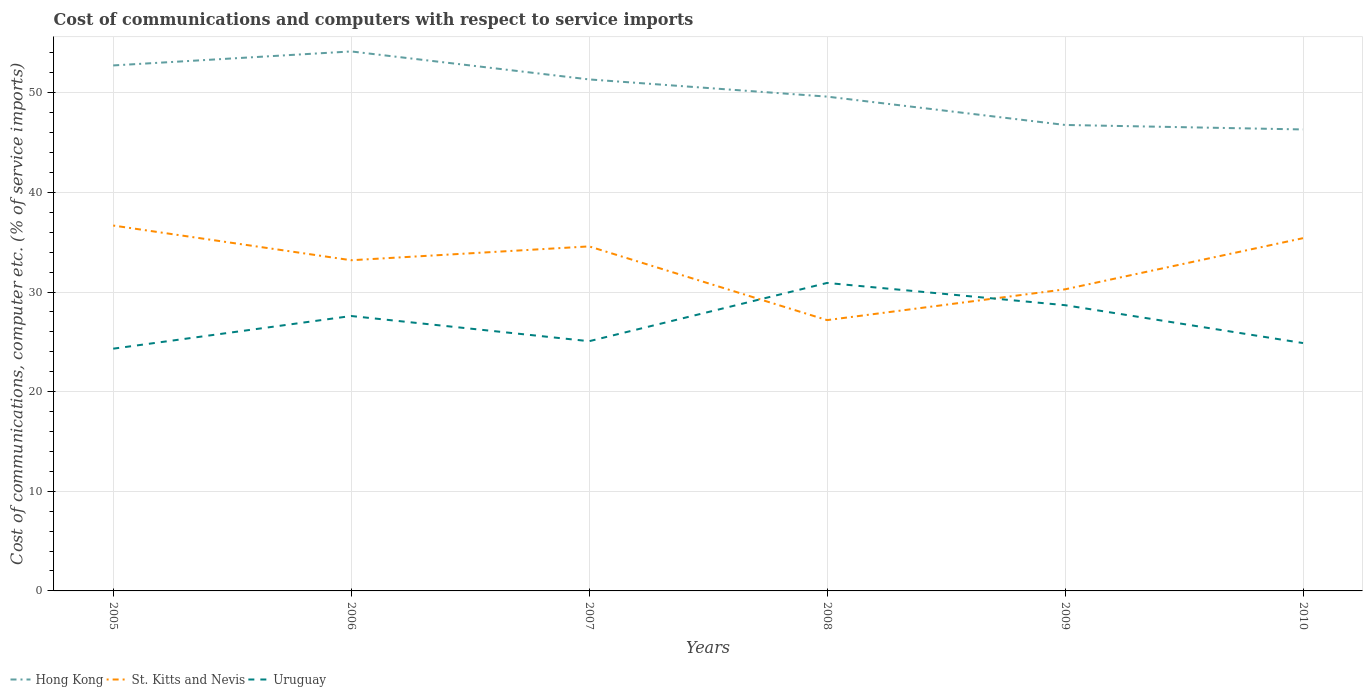How many different coloured lines are there?
Make the answer very short. 3. Does the line corresponding to Uruguay intersect with the line corresponding to Hong Kong?
Offer a terse response. No. Across all years, what is the maximum cost of communications and computers in Hong Kong?
Your answer should be very brief. 46.32. What is the total cost of communications and computers in Hong Kong in the graph?
Provide a succinct answer. 2.81. What is the difference between the highest and the second highest cost of communications and computers in Uruguay?
Offer a terse response. 6.6. Is the cost of communications and computers in Uruguay strictly greater than the cost of communications and computers in St. Kitts and Nevis over the years?
Your answer should be compact. No. How many lines are there?
Provide a succinct answer. 3. How many years are there in the graph?
Ensure brevity in your answer.  6. Are the values on the major ticks of Y-axis written in scientific E-notation?
Your answer should be very brief. No. Does the graph contain any zero values?
Keep it short and to the point. No. Where does the legend appear in the graph?
Ensure brevity in your answer.  Bottom left. How are the legend labels stacked?
Your answer should be compact. Horizontal. What is the title of the graph?
Ensure brevity in your answer.  Cost of communications and computers with respect to service imports. Does "Yemen, Rep." appear as one of the legend labels in the graph?
Give a very brief answer. No. What is the label or title of the Y-axis?
Offer a very short reply. Cost of communications, computer etc. (% of service imports). What is the Cost of communications, computer etc. (% of service imports) in Hong Kong in 2005?
Provide a short and direct response. 52.75. What is the Cost of communications, computer etc. (% of service imports) in St. Kitts and Nevis in 2005?
Offer a terse response. 36.68. What is the Cost of communications, computer etc. (% of service imports) of Uruguay in 2005?
Your response must be concise. 24.32. What is the Cost of communications, computer etc. (% of service imports) of Hong Kong in 2006?
Keep it short and to the point. 54.15. What is the Cost of communications, computer etc. (% of service imports) in St. Kitts and Nevis in 2006?
Offer a very short reply. 33.19. What is the Cost of communications, computer etc. (% of service imports) in Uruguay in 2006?
Keep it short and to the point. 27.6. What is the Cost of communications, computer etc. (% of service imports) of Hong Kong in 2007?
Make the answer very short. 51.34. What is the Cost of communications, computer etc. (% of service imports) of St. Kitts and Nevis in 2007?
Make the answer very short. 34.58. What is the Cost of communications, computer etc. (% of service imports) of Uruguay in 2007?
Keep it short and to the point. 25.07. What is the Cost of communications, computer etc. (% of service imports) of Hong Kong in 2008?
Give a very brief answer. 49.62. What is the Cost of communications, computer etc. (% of service imports) in St. Kitts and Nevis in 2008?
Provide a short and direct response. 27.18. What is the Cost of communications, computer etc. (% of service imports) of Uruguay in 2008?
Offer a very short reply. 30.91. What is the Cost of communications, computer etc. (% of service imports) of Hong Kong in 2009?
Provide a short and direct response. 46.77. What is the Cost of communications, computer etc. (% of service imports) of St. Kitts and Nevis in 2009?
Your answer should be compact. 30.27. What is the Cost of communications, computer etc. (% of service imports) of Uruguay in 2009?
Your answer should be very brief. 28.68. What is the Cost of communications, computer etc. (% of service imports) of Hong Kong in 2010?
Make the answer very short. 46.32. What is the Cost of communications, computer etc. (% of service imports) in St. Kitts and Nevis in 2010?
Your answer should be compact. 35.41. What is the Cost of communications, computer etc. (% of service imports) in Uruguay in 2010?
Offer a very short reply. 24.88. Across all years, what is the maximum Cost of communications, computer etc. (% of service imports) in Hong Kong?
Offer a terse response. 54.15. Across all years, what is the maximum Cost of communications, computer etc. (% of service imports) in St. Kitts and Nevis?
Your answer should be compact. 36.68. Across all years, what is the maximum Cost of communications, computer etc. (% of service imports) of Uruguay?
Offer a very short reply. 30.91. Across all years, what is the minimum Cost of communications, computer etc. (% of service imports) in Hong Kong?
Your answer should be compact. 46.32. Across all years, what is the minimum Cost of communications, computer etc. (% of service imports) of St. Kitts and Nevis?
Your response must be concise. 27.18. Across all years, what is the minimum Cost of communications, computer etc. (% of service imports) in Uruguay?
Ensure brevity in your answer.  24.32. What is the total Cost of communications, computer etc. (% of service imports) of Hong Kong in the graph?
Ensure brevity in your answer.  300.95. What is the total Cost of communications, computer etc. (% of service imports) in St. Kitts and Nevis in the graph?
Ensure brevity in your answer.  197.31. What is the total Cost of communications, computer etc. (% of service imports) in Uruguay in the graph?
Make the answer very short. 161.45. What is the difference between the Cost of communications, computer etc. (% of service imports) in Hong Kong in 2005 and that in 2006?
Make the answer very short. -1.41. What is the difference between the Cost of communications, computer etc. (% of service imports) of St. Kitts and Nevis in 2005 and that in 2006?
Provide a short and direct response. 3.48. What is the difference between the Cost of communications, computer etc. (% of service imports) in Uruguay in 2005 and that in 2006?
Offer a terse response. -3.28. What is the difference between the Cost of communications, computer etc. (% of service imports) in Hong Kong in 2005 and that in 2007?
Provide a succinct answer. 1.4. What is the difference between the Cost of communications, computer etc. (% of service imports) in St. Kitts and Nevis in 2005 and that in 2007?
Your answer should be very brief. 2.09. What is the difference between the Cost of communications, computer etc. (% of service imports) of Uruguay in 2005 and that in 2007?
Your answer should be very brief. -0.75. What is the difference between the Cost of communications, computer etc. (% of service imports) of Hong Kong in 2005 and that in 2008?
Ensure brevity in your answer.  3.13. What is the difference between the Cost of communications, computer etc. (% of service imports) in St. Kitts and Nevis in 2005 and that in 2008?
Your answer should be very brief. 9.49. What is the difference between the Cost of communications, computer etc. (% of service imports) in Uruguay in 2005 and that in 2008?
Offer a very short reply. -6.6. What is the difference between the Cost of communications, computer etc. (% of service imports) of Hong Kong in 2005 and that in 2009?
Ensure brevity in your answer.  5.97. What is the difference between the Cost of communications, computer etc. (% of service imports) in St. Kitts and Nevis in 2005 and that in 2009?
Your response must be concise. 6.4. What is the difference between the Cost of communications, computer etc. (% of service imports) of Uruguay in 2005 and that in 2009?
Your answer should be very brief. -4.37. What is the difference between the Cost of communications, computer etc. (% of service imports) of Hong Kong in 2005 and that in 2010?
Your answer should be very brief. 6.43. What is the difference between the Cost of communications, computer etc. (% of service imports) of St. Kitts and Nevis in 2005 and that in 2010?
Your answer should be very brief. 1.27. What is the difference between the Cost of communications, computer etc. (% of service imports) of Uruguay in 2005 and that in 2010?
Provide a succinct answer. -0.56. What is the difference between the Cost of communications, computer etc. (% of service imports) in Hong Kong in 2006 and that in 2007?
Give a very brief answer. 2.81. What is the difference between the Cost of communications, computer etc. (% of service imports) in St. Kitts and Nevis in 2006 and that in 2007?
Offer a very short reply. -1.39. What is the difference between the Cost of communications, computer etc. (% of service imports) of Uruguay in 2006 and that in 2007?
Ensure brevity in your answer.  2.53. What is the difference between the Cost of communications, computer etc. (% of service imports) of Hong Kong in 2006 and that in 2008?
Your answer should be very brief. 4.54. What is the difference between the Cost of communications, computer etc. (% of service imports) of St. Kitts and Nevis in 2006 and that in 2008?
Your answer should be very brief. 6.01. What is the difference between the Cost of communications, computer etc. (% of service imports) in Uruguay in 2006 and that in 2008?
Provide a short and direct response. -3.32. What is the difference between the Cost of communications, computer etc. (% of service imports) in Hong Kong in 2006 and that in 2009?
Your answer should be compact. 7.38. What is the difference between the Cost of communications, computer etc. (% of service imports) of St. Kitts and Nevis in 2006 and that in 2009?
Your response must be concise. 2.92. What is the difference between the Cost of communications, computer etc. (% of service imports) of Uruguay in 2006 and that in 2009?
Your answer should be very brief. -1.09. What is the difference between the Cost of communications, computer etc. (% of service imports) of Hong Kong in 2006 and that in 2010?
Provide a succinct answer. 7.83. What is the difference between the Cost of communications, computer etc. (% of service imports) of St. Kitts and Nevis in 2006 and that in 2010?
Offer a terse response. -2.21. What is the difference between the Cost of communications, computer etc. (% of service imports) of Uruguay in 2006 and that in 2010?
Offer a very short reply. 2.72. What is the difference between the Cost of communications, computer etc. (% of service imports) in Hong Kong in 2007 and that in 2008?
Offer a very short reply. 1.73. What is the difference between the Cost of communications, computer etc. (% of service imports) in St. Kitts and Nevis in 2007 and that in 2008?
Ensure brevity in your answer.  7.4. What is the difference between the Cost of communications, computer etc. (% of service imports) of Uruguay in 2007 and that in 2008?
Offer a very short reply. -5.85. What is the difference between the Cost of communications, computer etc. (% of service imports) of Hong Kong in 2007 and that in 2009?
Keep it short and to the point. 4.57. What is the difference between the Cost of communications, computer etc. (% of service imports) in St. Kitts and Nevis in 2007 and that in 2009?
Ensure brevity in your answer.  4.31. What is the difference between the Cost of communications, computer etc. (% of service imports) of Uruguay in 2007 and that in 2009?
Provide a succinct answer. -3.62. What is the difference between the Cost of communications, computer etc. (% of service imports) in Hong Kong in 2007 and that in 2010?
Offer a very short reply. 5.02. What is the difference between the Cost of communications, computer etc. (% of service imports) of St. Kitts and Nevis in 2007 and that in 2010?
Your response must be concise. -0.83. What is the difference between the Cost of communications, computer etc. (% of service imports) of Uruguay in 2007 and that in 2010?
Give a very brief answer. 0.19. What is the difference between the Cost of communications, computer etc. (% of service imports) of Hong Kong in 2008 and that in 2009?
Your response must be concise. 2.84. What is the difference between the Cost of communications, computer etc. (% of service imports) of St. Kitts and Nevis in 2008 and that in 2009?
Provide a succinct answer. -3.09. What is the difference between the Cost of communications, computer etc. (% of service imports) in Uruguay in 2008 and that in 2009?
Give a very brief answer. 2.23. What is the difference between the Cost of communications, computer etc. (% of service imports) of Hong Kong in 2008 and that in 2010?
Your answer should be compact. 3.3. What is the difference between the Cost of communications, computer etc. (% of service imports) of St. Kitts and Nevis in 2008 and that in 2010?
Keep it short and to the point. -8.23. What is the difference between the Cost of communications, computer etc. (% of service imports) in Uruguay in 2008 and that in 2010?
Your answer should be very brief. 6.03. What is the difference between the Cost of communications, computer etc. (% of service imports) of Hong Kong in 2009 and that in 2010?
Offer a very short reply. 0.45. What is the difference between the Cost of communications, computer etc. (% of service imports) in St. Kitts and Nevis in 2009 and that in 2010?
Your answer should be very brief. -5.13. What is the difference between the Cost of communications, computer etc. (% of service imports) of Uruguay in 2009 and that in 2010?
Your answer should be very brief. 3.8. What is the difference between the Cost of communications, computer etc. (% of service imports) of Hong Kong in 2005 and the Cost of communications, computer etc. (% of service imports) of St. Kitts and Nevis in 2006?
Your answer should be very brief. 19.55. What is the difference between the Cost of communications, computer etc. (% of service imports) in Hong Kong in 2005 and the Cost of communications, computer etc. (% of service imports) in Uruguay in 2006?
Offer a terse response. 25.15. What is the difference between the Cost of communications, computer etc. (% of service imports) in St. Kitts and Nevis in 2005 and the Cost of communications, computer etc. (% of service imports) in Uruguay in 2006?
Make the answer very short. 9.08. What is the difference between the Cost of communications, computer etc. (% of service imports) in Hong Kong in 2005 and the Cost of communications, computer etc. (% of service imports) in St. Kitts and Nevis in 2007?
Give a very brief answer. 18.16. What is the difference between the Cost of communications, computer etc. (% of service imports) of Hong Kong in 2005 and the Cost of communications, computer etc. (% of service imports) of Uruguay in 2007?
Your answer should be compact. 27.68. What is the difference between the Cost of communications, computer etc. (% of service imports) of St. Kitts and Nevis in 2005 and the Cost of communications, computer etc. (% of service imports) of Uruguay in 2007?
Make the answer very short. 11.61. What is the difference between the Cost of communications, computer etc. (% of service imports) of Hong Kong in 2005 and the Cost of communications, computer etc. (% of service imports) of St. Kitts and Nevis in 2008?
Your answer should be very brief. 25.56. What is the difference between the Cost of communications, computer etc. (% of service imports) in Hong Kong in 2005 and the Cost of communications, computer etc. (% of service imports) in Uruguay in 2008?
Keep it short and to the point. 21.83. What is the difference between the Cost of communications, computer etc. (% of service imports) in St. Kitts and Nevis in 2005 and the Cost of communications, computer etc. (% of service imports) in Uruguay in 2008?
Provide a succinct answer. 5.76. What is the difference between the Cost of communications, computer etc. (% of service imports) of Hong Kong in 2005 and the Cost of communications, computer etc. (% of service imports) of St. Kitts and Nevis in 2009?
Your answer should be very brief. 22.47. What is the difference between the Cost of communications, computer etc. (% of service imports) in Hong Kong in 2005 and the Cost of communications, computer etc. (% of service imports) in Uruguay in 2009?
Offer a terse response. 24.06. What is the difference between the Cost of communications, computer etc. (% of service imports) in St. Kitts and Nevis in 2005 and the Cost of communications, computer etc. (% of service imports) in Uruguay in 2009?
Give a very brief answer. 7.99. What is the difference between the Cost of communications, computer etc. (% of service imports) of Hong Kong in 2005 and the Cost of communications, computer etc. (% of service imports) of St. Kitts and Nevis in 2010?
Offer a very short reply. 17.34. What is the difference between the Cost of communications, computer etc. (% of service imports) of Hong Kong in 2005 and the Cost of communications, computer etc. (% of service imports) of Uruguay in 2010?
Give a very brief answer. 27.87. What is the difference between the Cost of communications, computer etc. (% of service imports) in St. Kitts and Nevis in 2005 and the Cost of communications, computer etc. (% of service imports) in Uruguay in 2010?
Provide a short and direct response. 11.8. What is the difference between the Cost of communications, computer etc. (% of service imports) in Hong Kong in 2006 and the Cost of communications, computer etc. (% of service imports) in St. Kitts and Nevis in 2007?
Provide a short and direct response. 19.57. What is the difference between the Cost of communications, computer etc. (% of service imports) in Hong Kong in 2006 and the Cost of communications, computer etc. (% of service imports) in Uruguay in 2007?
Ensure brevity in your answer.  29.09. What is the difference between the Cost of communications, computer etc. (% of service imports) of St. Kitts and Nevis in 2006 and the Cost of communications, computer etc. (% of service imports) of Uruguay in 2007?
Provide a succinct answer. 8.13. What is the difference between the Cost of communications, computer etc. (% of service imports) of Hong Kong in 2006 and the Cost of communications, computer etc. (% of service imports) of St. Kitts and Nevis in 2008?
Offer a terse response. 26.97. What is the difference between the Cost of communications, computer etc. (% of service imports) of Hong Kong in 2006 and the Cost of communications, computer etc. (% of service imports) of Uruguay in 2008?
Make the answer very short. 23.24. What is the difference between the Cost of communications, computer etc. (% of service imports) of St. Kitts and Nevis in 2006 and the Cost of communications, computer etc. (% of service imports) of Uruguay in 2008?
Your answer should be very brief. 2.28. What is the difference between the Cost of communications, computer etc. (% of service imports) of Hong Kong in 2006 and the Cost of communications, computer etc. (% of service imports) of St. Kitts and Nevis in 2009?
Make the answer very short. 23.88. What is the difference between the Cost of communications, computer etc. (% of service imports) of Hong Kong in 2006 and the Cost of communications, computer etc. (% of service imports) of Uruguay in 2009?
Give a very brief answer. 25.47. What is the difference between the Cost of communications, computer etc. (% of service imports) in St. Kitts and Nevis in 2006 and the Cost of communications, computer etc. (% of service imports) in Uruguay in 2009?
Make the answer very short. 4.51. What is the difference between the Cost of communications, computer etc. (% of service imports) in Hong Kong in 2006 and the Cost of communications, computer etc. (% of service imports) in St. Kitts and Nevis in 2010?
Your response must be concise. 18.74. What is the difference between the Cost of communications, computer etc. (% of service imports) in Hong Kong in 2006 and the Cost of communications, computer etc. (% of service imports) in Uruguay in 2010?
Your answer should be very brief. 29.27. What is the difference between the Cost of communications, computer etc. (% of service imports) of St. Kitts and Nevis in 2006 and the Cost of communications, computer etc. (% of service imports) of Uruguay in 2010?
Make the answer very short. 8.31. What is the difference between the Cost of communications, computer etc. (% of service imports) in Hong Kong in 2007 and the Cost of communications, computer etc. (% of service imports) in St. Kitts and Nevis in 2008?
Your answer should be compact. 24.16. What is the difference between the Cost of communications, computer etc. (% of service imports) of Hong Kong in 2007 and the Cost of communications, computer etc. (% of service imports) of Uruguay in 2008?
Offer a terse response. 20.43. What is the difference between the Cost of communications, computer etc. (% of service imports) in St. Kitts and Nevis in 2007 and the Cost of communications, computer etc. (% of service imports) in Uruguay in 2008?
Provide a succinct answer. 3.67. What is the difference between the Cost of communications, computer etc. (% of service imports) of Hong Kong in 2007 and the Cost of communications, computer etc. (% of service imports) of St. Kitts and Nevis in 2009?
Offer a terse response. 21.07. What is the difference between the Cost of communications, computer etc. (% of service imports) in Hong Kong in 2007 and the Cost of communications, computer etc. (% of service imports) in Uruguay in 2009?
Your response must be concise. 22.66. What is the difference between the Cost of communications, computer etc. (% of service imports) of St. Kitts and Nevis in 2007 and the Cost of communications, computer etc. (% of service imports) of Uruguay in 2009?
Give a very brief answer. 5.9. What is the difference between the Cost of communications, computer etc. (% of service imports) in Hong Kong in 2007 and the Cost of communications, computer etc. (% of service imports) in St. Kitts and Nevis in 2010?
Your answer should be very brief. 15.93. What is the difference between the Cost of communications, computer etc. (% of service imports) of Hong Kong in 2007 and the Cost of communications, computer etc. (% of service imports) of Uruguay in 2010?
Give a very brief answer. 26.46. What is the difference between the Cost of communications, computer etc. (% of service imports) in St. Kitts and Nevis in 2007 and the Cost of communications, computer etc. (% of service imports) in Uruguay in 2010?
Provide a succinct answer. 9.7. What is the difference between the Cost of communications, computer etc. (% of service imports) in Hong Kong in 2008 and the Cost of communications, computer etc. (% of service imports) in St. Kitts and Nevis in 2009?
Give a very brief answer. 19.34. What is the difference between the Cost of communications, computer etc. (% of service imports) of Hong Kong in 2008 and the Cost of communications, computer etc. (% of service imports) of Uruguay in 2009?
Make the answer very short. 20.93. What is the difference between the Cost of communications, computer etc. (% of service imports) in St. Kitts and Nevis in 2008 and the Cost of communications, computer etc. (% of service imports) in Uruguay in 2009?
Offer a very short reply. -1.5. What is the difference between the Cost of communications, computer etc. (% of service imports) of Hong Kong in 2008 and the Cost of communications, computer etc. (% of service imports) of St. Kitts and Nevis in 2010?
Give a very brief answer. 14.21. What is the difference between the Cost of communications, computer etc. (% of service imports) of Hong Kong in 2008 and the Cost of communications, computer etc. (% of service imports) of Uruguay in 2010?
Provide a short and direct response. 24.74. What is the difference between the Cost of communications, computer etc. (% of service imports) in St. Kitts and Nevis in 2008 and the Cost of communications, computer etc. (% of service imports) in Uruguay in 2010?
Ensure brevity in your answer.  2.3. What is the difference between the Cost of communications, computer etc. (% of service imports) of Hong Kong in 2009 and the Cost of communications, computer etc. (% of service imports) of St. Kitts and Nevis in 2010?
Ensure brevity in your answer.  11.36. What is the difference between the Cost of communications, computer etc. (% of service imports) in Hong Kong in 2009 and the Cost of communications, computer etc. (% of service imports) in Uruguay in 2010?
Your response must be concise. 21.89. What is the difference between the Cost of communications, computer etc. (% of service imports) in St. Kitts and Nevis in 2009 and the Cost of communications, computer etc. (% of service imports) in Uruguay in 2010?
Ensure brevity in your answer.  5.39. What is the average Cost of communications, computer etc. (% of service imports) of Hong Kong per year?
Ensure brevity in your answer.  50.16. What is the average Cost of communications, computer etc. (% of service imports) of St. Kitts and Nevis per year?
Make the answer very short. 32.89. What is the average Cost of communications, computer etc. (% of service imports) of Uruguay per year?
Your answer should be compact. 26.91. In the year 2005, what is the difference between the Cost of communications, computer etc. (% of service imports) of Hong Kong and Cost of communications, computer etc. (% of service imports) of St. Kitts and Nevis?
Give a very brief answer. 16.07. In the year 2005, what is the difference between the Cost of communications, computer etc. (% of service imports) of Hong Kong and Cost of communications, computer etc. (% of service imports) of Uruguay?
Offer a terse response. 28.43. In the year 2005, what is the difference between the Cost of communications, computer etc. (% of service imports) in St. Kitts and Nevis and Cost of communications, computer etc. (% of service imports) in Uruguay?
Your answer should be very brief. 12.36. In the year 2006, what is the difference between the Cost of communications, computer etc. (% of service imports) in Hong Kong and Cost of communications, computer etc. (% of service imports) in St. Kitts and Nevis?
Keep it short and to the point. 20.96. In the year 2006, what is the difference between the Cost of communications, computer etc. (% of service imports) in Hong Kong and Cost of communications, computer etc. (% of service imports) in Uruguay?
Provide a succinct answer. 26.56. In the year 2006, what is the difference between the Cost of communications, computer etc. (% of service imports) of St. Kitts and Nevis and Cost of communications, computer etc. (% of service imports) of Uruguay?
Give a very brief answer. 5.6. In the year 2007, what is the difference between the Cost of communications, computer etc. (% of service imports) in Hong Kong and Cost of communications, computer etc. (% of service imports) in St. Kitts and Nevis?
Offer a very short reply. 16.76. In the year 2007, what is the difference between the Cost of communications, computer etc. (% of service imports) in Hong Kong and Cost of communications, computer etc. (% of service imports) in Uruguay?
Your answer should be very brief. 26.28. In the year 2007, what is the difference between the Cost of communications, computer etc. (% of service imports) in St. Kitts and Nevis and Cost of communications, computer etc. (% of service imports) in Uruguay?
Make the answer very short. 9.52. In the year 2008, what is the difference between the Cost of communications, computer etc. (% of service imports) in Hong Kong and Cost of communications, computer etc. (% of service imports) in St. Kitts and Nevis?
Offer a very short reply. 22.43. In the year 2008, what is the difference between the Cost of communications, computer etc. (% of service imports) in Hong Kong and Cost of communications, computer etc. (% of service imports) in Uruguay?
Your response must be concise. 18.7. In the year 2008, what is the difference between the Cost of communications, computer etc. (% of service imports) of St. Kitts and Nevis and Cost of communications, computer etc. (% of service imports) of Uruguay?
Ensure brevity in your answer.  -3.73. In the year 2009, what is the difference between the Cost of communications, computer etc. (% of service imports) of Hong Kong and Cost of communications, computer etc. (% of service imports) of St. Kitts and Nevis?
Your answer should be compact. 16.5. In the year 2009, what is the difference between the Cost of communications, computer etc. (% of service imports) in Hong Kong and Cost of communications, computer etc. (% of service imports) in Uruguay?
Provide a short and direct response. 18.09. In the year 2009, what is the difference between the Cost of communications, computer etc. (% of service imports) of St. Kitts and Nevis and Cost of communications, computer etc. (% of service imports) of Uruguay?
Make the answer very short. 1.59. In the year 2010, what is the difference between the Cost of communications, computer etc. (% of service imports) in Hong Kong and Cost of communications, computer etc. (% of service imports) in St. Kitts and Nevis?
Keep it short and to the point. 10.91. In the year 2010, what is the difference between the Cost of communications, computer etc. (% of service imports) of Hong Kong and Cost of communications, computer etc. (% of service imports) of Uruguay?
Provide a succinct answer. 21.44. In the year 2010, what is the difference between the Cost of communications, computer etc. (% of service imports) in St. Kitts and Nevis and Cost of communications, computer etc. (% of service imports) in Uruguay?
Provide a succinct answer. 10.53. What is the ratio of the Cost of communications, computer etc. (% of service imports) of Hong Kong in 2005 to that in 2006?
Your response must be concise. 0.97. What is the ratio of the Cost of communications, computer etc. (% of service imports) in St. Kitts and Nevis in 2005 to that in 2006?
Your response must be concise. 1.1. What is the ratio of the Cost of communications, computer etc. (% of service imports) of Uruguay in 2005 to that in 2006?
Provide a succinct answer. 0.88. What is the ratio of the Cost of communications, computer etc. (% of service imports) in Hong Kong in 2005 to that in 2007?
Offer a terse response. 1.03. What is the ratio of the Cost of communications, computer etc. (% of service imports) of St. Kitts and Nevis in 2005 to that in 2007?
Your answer should be compact. 1.06. What is the ratio of the Cost of communications, computer etc. (% of service imports) in Uruguay in 2005 to that in 2007?
Provide a short and direct response. 0.97. What is the ratio of the Cost of communications, computer etc. (% of service imports) of Hong Kong in 2005 to that in 2008?
Give a very brief answer. 1.06. What is the ratio of the Cost of communications, computer etc. (% of service imports) in St. Kitts and Nevis in 2005 to that in 2008?
Keep it short and to the point. 1.35. What is the ratio of the Cost of communications, computer etc. (% of service imports) in Uruguay in 2005 to that in 2008?
Your answer should be very brief. 0.79. What is the ratio of the Cost of communications, computer etc. (% of service imports) in Hong Kong in 2005 to that in 2009?
Keep it short and to the point. 1.13. What is the ratio of the Cost of communications, computer etc. (% of service imports) of St. Kitts and Nevis in 2005 to that in 2009?
Offer a very short reply. 1.21. What is the ratio of the Cost of communications, computer etc. (% of service imports) of Uruguay in 2005 to that in 2009?
Provide a short and direct response. 0.85. What is the ratio of the Cost of communications, computer etc. (% of service imports) in Hong Kong in 2005 to that in 2010?
Offer a very short reply. 1.14. What is the ratio of the Cost of communications, computer etc. (% of service imports) in St. Kitts and Nevis in 2005 to that in 2010?
Give a very brief answer. 1.04. What is the ratio of the Cost of communications, computer etc. (% of service imports) of Uruguay in 2005 to that in 2010?
Offer a terse response. 0.98. What is the ratio of the Cost of communications, computer etc. (% of service imports) in Hong Kong in 2006 to that in 2007?
Make the answer very short. 1.05. What is the ratio of the Cost of communications, computer etc. (% of service imports) of St. Kitts and Nevis in 2006 to that in 2007?
Offer a very short reply. 0.96. What is the ratio of the Cost of communications, computer etc. (% of service imports) of Uruguay in 2006 to that in 2007?
Your response must be concise. 1.1. What is the ratio of the Cost of communications, computer etc. (% of service imports) in Hong Kong in 2006 to that in 2008?
Your answer should be very brief. 1.09. What is the ratio of the Cost of communications, computer etc. (% of service imports) in St. Kitts and Nevis in 2006 to that in 2008?
Offer a very short reply. 1.22. What is the ratio of the Cost of communications, computer etc. (% of service imports) of Uruguay in 2006 to that in 2008?
Your answer should be very brief. 0.89. What is the ratio of the Cost of communications, computer etc. (% of service imports) in Hong Kong in 2006 to that in 2009?
Your response must be concise. 1.16. What is the ratio of the Cost of communications, computer etc. (% of service imports) in St. Kitts and Nevis in 2006 to that in 2009?
Keep it short and to the point. 1.1. What is the ratio of the Cost of communications, computer etc. (% of service imports) of Uruguay in 2006 to that in 2009?
Make the answer very short. 0.96. What is the ratio of the Cost of communications, computer etc. (% of service imports) of Hong Kong in 2006 to that in 2010?
Your answer should be very brief. 1.17. What is the ratio of the Cost of communications, computer etc. (% of service imports) in St. Kitts and Nevis in 2006 to that in 2010?
Offer a very short reply. 0.94. What is the ratio of the Cost of communications, computer etc. (% of service imports) of Uruguay in 2006 to that in 2010?
Provide a succinct answer. 1.11. What is the ratio of the Cost of communications, computer etc. (% of service imports) of Hong Kong in 2007 to that in 2008?
Your answer should be very brief. 1.03. What is the ratio of the Cost of communications, computer etc. (% of service imports) of St. Kitts and Nevis in 2007 to that in 2008?
Provide a short and direct response. 1.27. What is the ratio of the Cost of communications, computer etc. (% of service imports) of Uruguay in 2007 to that in 2008?
Make the answer very short. 0.81. What is the ratio of the Cost of communications, computer etc. (% of service imports) of Hong Kong in 2007 to that in 2009?
Offer a very short reply. 1.1. What is the ratio of the Cost of communications, computer etc. (% of service imports) of St. Kitts and Nevis in 2007 to that in 2009?
Give a very brief answer. 1.14. What is the ratio of the Cost of communications, computer etc. (% of service imports) of Uruguay in 2007 to that in 2009?
Your response must be concise. 0.87. What is the ratio of the Cost of communications, computer etc. (% of service imports) in Hong Kong in 2007 to that in 2010?
Ensure brevity in your answer.  1.11. What is the ratio of the Cost of communications, computer etc. (% of service imports) in St. Kitts and Nevis in 2007 to that in 2010?
Make the answer very short. 0.98. What is the ratio of the Cost of communications, computer etc. (% of service imports) of Uruguay in 2007 to that in 2010?
Keep it short and to the point. 1.01. What is the ratio of the Cost of communications, computer etc. (% of service imports) of Hong Kong in 2008 to that in 2009?
Keep it short and to the point. 1.06. What is the ratio of the Cost of communications, computer etc. (% of service imports) of St. Kitts and Nevis in 2008 to that in 2009?
Keep it short and to the point. 0.9. What is the ratio of the Cost of communications, computer etc. (% of service imports) of Uruguay in 2008 to that in 2009?
Keep it short and to the point. 1.08. What is the ratio of the Cost of communications, computer etc. (% of service imports) in Hong Kong in 2008 to that in 2010?
Keep it short and to the point. 1.07. What is the ratio of the Cost of communications, computer etc. (% of service imports) of St. Kitts and Nevis in 2008 to that in 2010?
Offer a terse response. 0.77. What is the ratio of the Cost of communications, computer etc. (% of service imports) in Uruguay in 2008 to that in 2010?
Provide a succinct answer. 1.24. What is the ratio of the Cost of communications, computer etc. (% of service imports) in Hong Kong in 2009 to that in 2010?
Provide a short and direct response. 1.01. What is the ratio of the Cost of communications, computer etc. (% of service imports) of St. Kitts and Nevis in 2009 to that in 2010?
Ensure brevity in your answer.  0.85. What is the ratio of the Cost of communications, computer etc. (% of service imports) of Uruguay in 2009 to that in 2010?
Keep it short and to the point. 1.15. What is the difference between the highest and the second highest Cost of communications, computer etc. (% of service imports) in Hong Kong?
Provide a succinct answer. 1.41. What is the difference between the highest and the second highest Cost of communications, computer etc. (% of service imports) in St. Kitts and Nevis?
Offer a terse response. 1.27. What is the difference between the highest and the second highest Cost of communications, computer etc. (% of service imports) of Uruguay?
Your answer should be compact. 2.23. What is the difference between the highest and the lowest Cost of communications, computer etc. (% of service imports) of Hong Kong?
Provide a short and direct response. 7.83. What is the difference between the highest and the lowest Cost of communications, computer etc. (% of service imports) in St. Kitts and Nevis?
Offer a terse response. 9.49. What is the difference between the highest and the lowest Cost of communications, computer etc. (% of service imports) of Uruguay?
Your answer should be very brief. 6.6. 